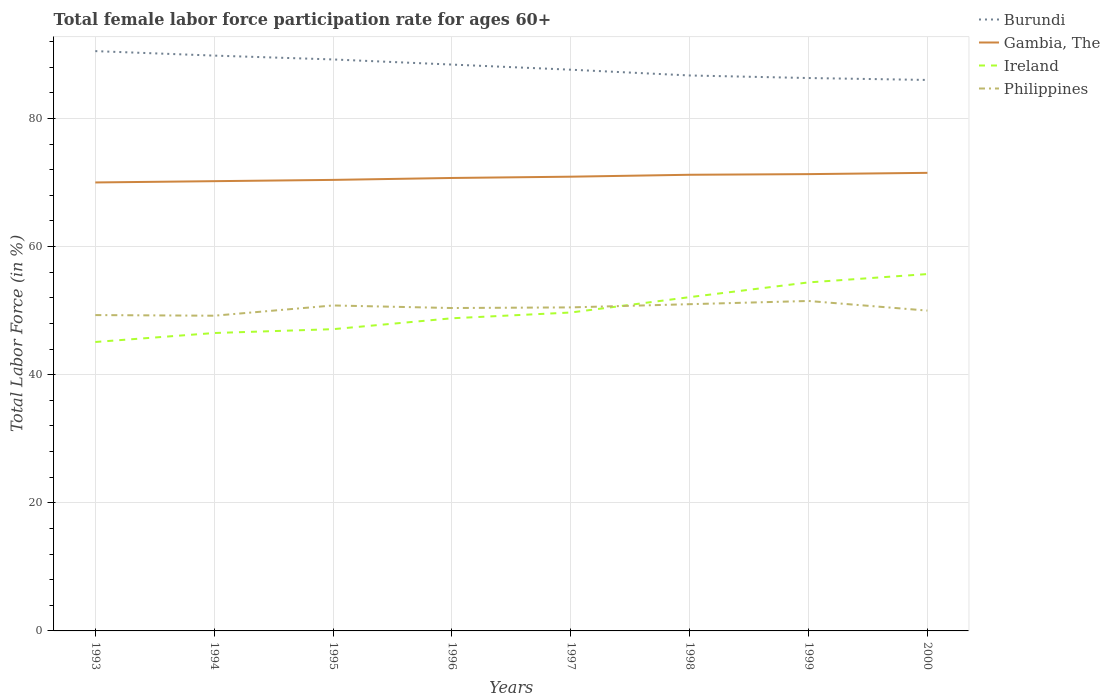How many different coloured lines are there?
Your response must be concise. 4. Does the line corresponding to Burundi intersect with the line corresponding to Ireland?
Offer a terse response. No. Across all years, what is the maximum female labor force participation rate in Philippines?
Provide a succinct answer. 49.2. In which year was the female labor force participation rate in Philippines maximum?
Provide a short and direct response. 1994. What is the total female labor force participation rate in Burundi in the graph?
Provide a succinct answer. 3.1. What is the difference between the highest and the second highest female labor force participation rate in Gambia, The?
Give a very brief answer. 1.5. What is the difference between the highest and the lowest female labor force participation rate in Ireland?
Provide a succinct answer. 3. Is the female labor force participation rate in Philippines strictly greater than the female labor force participation rate in Ireland over the years?
Your answer should be compact. No. How many years are there in the graph?
Give a very brief answer. 8. Are the values on the major ticks of Y-axis written in scientific E-notation?
Your answer should be compact. No. Does the graph contain any zero values?
Your answer should be compact. No. Where does the legend appear in the graph?
Your answer should be very brief. Top right. What is the title of the graph?
Give a very brief answer. Total female labor force participation rate for ages 60+. Does "Bosnia and Herzegovina" appear as one of the legend labels in the graph?
Give a very brief answer. No. What is the Total Labor Force (in %) of Burundi in 1993?
Give a very brief answer. 90.5. What is the Total Labor Force (in %) of Ireland in 1993?
Your response must be concise. 45.1. What is the Total Labor Force (in %) of Philippines in 1993?
Give a very brief answer. 49.3. What is the Total Labor Force (in %) of Burundi in 1994?
Keep it short and to the point. 89.8. What is the Total Labor Force (in %) in Gambia, The in 1994?
Provide a succinct answer. 70.2. What is the Total Labor Force (in %) of Ireland in 1994?
Provide a succinct answer. 46.5. What is the Total Labor Force (in %) of Philippines in 1994?
Keep it short and to the point. 49.2. What is the Total Labor Force (in %) in Burundi in 1995?
Give a very brief answer. 89.2. What is the Total Labor Force (in %) in Gambia, The in 1995?
Offer a very short reply. 70.4. What is the Total Labor Force (in %) in Ireland in 1995?
Offer a very short reply. 47.1. What is the Total Labor Force (in %) in Philippines in 1995?
Keep it short and to the point. 50.8. What is the Total Labor Force (in %) in Burundi in 1996?
Give a very brief answer. 88.4. What is the Total Labor Force (in %) of Gambia, The in 1996?
Your answer should be very brief. 70.7. What is the Total Labor Force (in %) of Ireland in 1996?
Offer a very short reply. 48.8. What is the Total Labor Force (in %) of Philippines in 1996?
Offer a very short reply. 50.4. What is the Total Labor Force (in %) of Burundi in 1997?
Provide a succinct answer. 87.6. What is the Total Labor Force (in %) in Gambia, The in 1997?
Provide a short and direct response. 70.9. What is the Total Labor Force (in %) in Ireland in 1997?
Your response must be concise. 49.7. What is the Total Labor Force (in %) of Philippines in 1997?
Give a very brief answer. 50.5. What is the Total Labor Force (in %) of Burundi in 1998?
Make the answer very short. 86.7. What is the Total Labor Force (in %) of Gambia, The in 1998?
Your response must be concise. 71.2. What is the Total Labor Force (in %) in Ireland in 1998?
Offer a terse response. 52.1. What is the Total Labor Force (in %) of Burundi in 1999?
Keep it short and to the point. 86.3. What is the Total Labor Force (in %) in Gambia, The in 1999?
Ensure brevity in your answer.  71.3. What is the Total Labor Force (in %) of Ireland in 1999?
Keep it short and to the point. 54.4. What is the Total Labor Force (in %) in Philippines in 1999?
Offer a terse response. 51.5. What is the Total Labor Force (in %) in Burundi in 2000?
Ensure brevity in your answer.  86. What is the Total Labor Force (in %) of Gambia, The in 2000?
Provide a succinct answer. 71.5. What is the Total Labor Force (in %) of Ireland in 2000?
Make the answer very short. 55.7. Across all years, what is the maximum Total Labor Force (in %) in Burundi?
Provide a short and direct response. 90.5. Across all years, what is the maximum Total Labor Force (in %) in Gambia, The?
Keep it short and to the point. 71.5. Across all years, what is the maximum Total Labor Force (in %) in Ireland?
Provide a succinct answer. 55.7. Across all years, what is the maximum Total Labor Force (in %) of Philippines?
Provide a succinct answer. 51.5. Across all years, what is the minimum Total Labor Force (in %) of Ireland?
Your answer should be very brief. 45.1. Across all years, what is the minimum Total Labor Force (in %) of Philippines?
Your answer should be compact. 49.2. What is the total Total Labor Force (in %) in Burundi in the graph?
Your answer should be compact. 704.5. What is the total Total Labor Force (in %) in Gambia, The in the graph?
Offer a very short reply. 566.2. What is the total Total Labor Force (in %) of Ireland in the graph?
Ensure brevity in your answer.  399.4. What is the total Total Labor Force (in %) of Philippines in the graph?
Give a very brief answer. 402.7. What is the difference between the Total Labor Force (in %) of Ireland in 1993 and that in 1994?
Offer a very short reply. -1.4. What is the difference between the Total Labor Force (in %) in Burundi in 1993 and that in 1995?
Offer a very short reply. 1.3. What is the difference between the Total Labor Force (in %) in Gambia, The in 1993 and that in 1995?
Provide a succinct answer. -0.4. What is the difference between the Total Labor Force (in %) of Philippines in 1993 and that in 1995?
Your response must be concise. -1.5. What is the difference between the Total Labor Force (in %) of Gambia, The in 1993 and that in 1996?
Keep it short and to the point. -0.7. What is the difference between the Total Labor Force (in %) of Ireland in 1993 and that in 1996?
Your answer should be very brief. -3.7. What is the difference between the Total Labor Force (in %) of Gambia, The in 1993 and that in 1997?
Your answer should be very brief. -0.9. What is the difference between the Total Labor Force (in %) of Ireland in 1993 and that in 1997?
Offer a very short reply. -4.6. What is the difference between the Total Labor Force (in %) in Philippines in 1993 and that in 1998?
Offer a terse response. -1.7. What is the difference between the Total Labor Force (in %) of Philippines in 1993 and that in 1999?
Provide a succinct answer. -2.2. What is the difference between the Total Labor Force (in %) of Burundi in 1993 and that in 2000?
Keep it short and to the point. 4.5. What is the difference between the Total Labor Force (in %) of Philippines in 1993 and that in 2000?
Provide a short and direct response. -0.7. What is the difference between the Total Labor Force (in %) in Burundi in 1994 and that in 1995?
Provide a short and direct response. 0.6. What is the difference between the Total Labor Force (in %) of Gambia, The in 1994 and that in 1995?
Keep it short and to the point. -0.2. What is the difference between the Total Labor Force (in %) in Ireland in 1994 and that in 1995?
Offer a very short reply. -0.6. What is the difference between the Total Labor Force (in %) of Gambia, The in 1994 and that in 1996?
Give a very brief answer. -0.5. What is the difference between the Total Labor Force (in %) in Ireland in 1994 and that in 1996?
Offer a terse response. -2.3. What is the difference between the Total Labor Force (in %) of Burundi in 1994 and that in 1997?
Your response must be concise. 2.2. What is the difference between the Total Labor Force (in %) of Burundi in 1994 and that in 1998?
Keep it short and to the point. 3.1. What is the difference between the Total Labor Force (in %) in Burundi in 1994 and that in 1999?
Provide a short and direct response. 3.5. What is the difference between the Total Labor Force (in %) in Gambia, The in 1994 and that in 1999?
Provide a short and direct response. -1.1. What is the difference between the Total Labor Force (in %) in Philippines in 1994 and that in 1999?
Your answer should be compact. -2.3. What is the difference between the Total Labor Force (in %) of Ireland in 1994 and that in 2000?
Keep it short and to the point. -9.2. What is the difference between the Total Labor Force (in %) of Philippines in 1994 and that in 2000?
Your answer should be compact. -0.8. What is the difference between the Total Labor Force (in %) in Burundi in 1995 and that in 1996?
Offer a very short reply. 0.8. What is the difference between the Total Labor Force (in %) of Gambia, The in 1995 and that in 1996?
Your answer should be very brief. -0.3. What is the difference between the Total Labor Force (in %) of Philippines in 1995 and that in 1996?
Provide a succinct answer. 0.4. What is the difference between the Total Labor Force (in %) of Gambia, The in 1995 and that in 1997?
Your response must be concise. -0.5. What is the difference between the Total Labor Force (in %) of Philippines in 1995 and that in 1997?
Your response must be concise. 0.3. What is the difference between the Total Labor Force (in %) in Burundi in 1995 and that in 1998?
Your response must be concise. 2.5. What is the difference between the Total Labor Force (in %) in Philippines in 1995 and that in 1998?
Your answer should be very brief. -0.2. What is the difference between the Total Labor Force (in %) in Burundi in 1995 and that in 1999?
Make the answer very short. 2.9. What is the difference between the Total Labor Force (in %) in Gambia, The in 1995 and that in 1999?
Keep it short and to the point. -0.9. What is the difference between the Total Labor Force (in %) of Philippines in 1995 and that in 1999?
Ensure brevity in your answer.  -0.7. What is the difference between the Total Labor Force (in %) of Burundi in 1995 and that in 2000?
Provide a short and direct response. 3.2. What is the difference between the Total Labor Force (in %) of Philippines in 1995 and that in 2000?
Offer a very short reply. 0.8. What is the difference between the Total Labor Force (in %) of Burundi in 1996 and that in 1997?
Ensure brevity in your answer.  0.8. What is the difference between the Total Labor Force (in %) of Burundi in 1996 and that in 1999?
Keep it short and to the point. 2.1. What is the difference between the Total Labor Force (in %) of Gambia, The in 1996 and that in 1999?
Ensure brevity in your answer.  -0.6. What is the difference between the Total Labor Force (in %) of Ireland in 1996 and that in 1999?
Offer a terse response. -5.6. What is the difference between the Total Labor Force (in %) of Ireland in 1996 and that in 2000?
Ensure brevity in your answer.  -6.9. What is the difference between the Total Labor Force (in %) of Burundi in 1997 and that in 1998?
Offer a terse response. 0.9. What is the difference between the Total Labor Force (in %) in Ireland in 1997 and that in 1998?
Offer a terse response. -2.4. What is the difference between the Total Labor Force (in %) in Burundi in 1997 and that in 1999?
Your response must be concise. 1.3. What is the difference between the Total Labor Force (in %) in Philippines in 1997 and that in 1999?
Provide a short and direct response. -1. What is the difference between the Total Labor Force (in %) in Philippines in 1997 and that in 2000?
Keep it short and to the point. 0.5. What is the difference between the Total Labor Force (in %) in Burundi in 1998 and that in 1999?
Keep it short and to the point. 0.4. What is the difference between the Total Labor Force (in %) in Gambia, The in 1998 and that in 1999?
Provide a short and direct response. -0.1. What is the difference between the Total Labor Force (in %) in Philippines in 1998 and that in 1999?
Your answer should be very brief. -0.5. What is the difference between the Total Labor Force (in %) in Gambia, The in 1998 and that in 2000?
Ensure brevity in your answer.  -0.3. What is the difference between the Total Labor Force (in %) in Ireland in 1998 and that in 2000?
Make the answer very short. -3.6. What is the difference between the Total Labor Force (in %) in Philippines in 1999 and that in 2000?
Offer a terse response. 1.5. What is the difference between the Total Labor Force (in %) of Burundi in 1993 and the Total Labor Force (in %) of Gambia, The in 1994?
Offer a very short reply. 20.3. What is the difference between the Total Labor Force (in %) of Burundi in 1993 and the Total Labor Force (in %) of Ireland in 1994?
Provide a short and direct response. 44. What is the difference between the Total Labor Force (in %) of Burundi in 1993 and the Total Labor Force (in %) of Philippines in 1994?
Offer a terse response. 41.3. What is the difference between the Total Labor Force (in %) of Gambia, The in 1993 and the Total Labor Force (in %) of Ireland in 1994?
Offer a very short reply. 23.5. What is the difference between the Total Labor Force (in %) in Gambia, The in 1993 and the Total Labor Force (in %) in Philippines in 1994?
Offer a terse response. 20.8. What is the difference between the Total Labor Force (in %) of Burundi in 1993 and the Total Labor Force (in %) of Gambia, The in 1995?
Make the answer very short. 20.1. What is the difference between the Total Labor Force (in %) of Burundi in 1993 and the Total Labor Force (in %) of Ireland in 1995?
Keep it short and to the point. 43.4. What is the difference between the Total Labor Force (in %) in Burundi in 1993 and the Total Labor Force (in %) in Philippines in 1995?
Offer a terse response. 39.7. What is the difference between the Total Labor Force (in %) in Gambia, The in 1993 and the Total Labor Force (in %) in Ireland in 1995?
Ensure brevity in your answer.  22.9. What is the difference between the Total Labor Force (in %) of Gambia, The in 1993 and the Total Labor Force (in %) of Philippines in 1995?
Provide a short and direct response. 19.2. What is the difference between the Total Labor Force (in %) in Burundi in 1993 and the Total Labor Force (in %) in Gambia, The in 1996?
Your answer should be very brief. 19.8. What is the difference between the Total Labor Force (in %) in Burundi in 1993 and the Total Labor Force (in %) in Ireland in 1996?
Your response must be concise. 41.7. What is the difference between the Total Labor Force (in %) of Burundi in 1993 and the Total Labor Force (in %) of Philippines in 1996?
Offer a very short reply. 40.1. What is the difference between the Total Labor Force (in %) of Gambia, The in 1993 and the Total Labor Force (in %) of Ireland in 1996?
Provide a succinct answer. 21.2. What is the difference between the Total Labor Force (in %) of Gambia, The in 1993 and the Total Labor Force (in %) of Philippines in 1996?
Your answer should be compact. 19.6. What is the difference between the Total Labor Force (in %) in Burundi in 1993 and the Total Labor Force (in %) in Gambia, The in 1997?
Provide a short and direct response. 19.6. What is the difference between the Total Labor Force (in %) of Burundi in 1993 and the Total Labor Force (in %) of Ireland in 1997?
Provide a succinct answer. 40.8. What is the difference between the Total Labor Force (in %) of Gambia, The in 1993 and the Total Labor Force (in %) of Ireland in 1997?
Your answer should be very brief. 20.3. What is the difference between the Total Labor Force (in %) of Ireland in 1993 and the Total Labor Force (in %) of Philippines in 1997?
Ensure brevity in your answer.  -5.4. What is the difference between the Total Labor Force (in %) of Burundi in 1993 and the Total Labor Force (in %) of Gambia, The in 1998?
Keep it short and to the point. 19.3. What is the difference between the Total Labor Force (in %) of Burundi in 1993 and the Total Labor Force (in %) of Ireland in 1998?
Your response must be concise. 38.4. What is the difference between the Total Labor Force (in %) of Burundi in 1993 and the Total Labor Force (in %) of Philippines in 1998?
Your answer should be very brief. 39.5. What is the difference between the Total Labor Force (in %) of Gambia, The in 1993 and the Total Labor Force (in %) of Ireland in 1998?
Provide a succinct answer. 17.9. What is the difference between the Total Labor Force (in %) in Gambia, The in 1993 and the Total Labor Force (in %) in Philippines in 1998?
Your answer should be very brief. 19. What is the difference between the Total Labor Force (in %) of Ireland in 1993 and the Total Labor Force (in %) of Philippines in 1998?
Your response must be concise. -5.9. What is the difference between the Total Labor Force (in %) of Burundi in 1993 and the Total Labor Force (in %) of Gambia, The in 1999?
Offer a very short reply. 19.2. What is the difference between the Total Labor Force (in %) of Burundi in 1993 and the Total Labor Force (in %) of Ireland in 1999?
Your answer should be compact. 36.1. What is the difference between the Total Labor Force (in %) in Gambia, The in 1993 and the Total Labor Force (in %) in Ireland in 1999?
Give a very brief answer. 15.6. What is the difference between the Total Labor Force (in %) in Burundi in 1993 and the Total Labor Force (in %) in Ireland in 2000?
Keep it short and to the point. 34.8. What is the difference between the Total Labor Force (in %) of Burundi in 1993 and the Total Labor Force (in %) of Philippines in 2000?
Make the answer very short. 40.5. What is the difference between the Total Labor Force (in %) in Gambia, The in 1993 and the Total Labor Force (in %) in Ireland in 2000?
Ensure brevity in your answer.  14.3. What is the difference between the Total Labor Force (in %) in Gambia, The in 1993 and the Total Labor Force (in %) in Philippines in 2000?
Provide a short and direct response. 20. What is the difference between the Total Labor Force (in %) in Ireland in 1993 and the Total Labor Force (in %) in Philippines in 2000?
Provide a succinct answer. -4.9. What is the difference between the Total Labor Force (in %) in Burundi in 1994 and the Total Labor Force (in %) in Gambia, The in 1995?
Provide a short and direct response. 19.4. What is the difference between the Total Labor Force (in %) in Burundi in 1994 and the Total Labor Force (in %) in Ireland in 1995?
Offer a very short reply. 42.7. What is the difference between the Total Labor Force (in %) of Burundi in 1994 and the Total Labor Force (in %) of Philippines in 1995?
Your response must be concise. 39. What is the difference between the Total Labor Force (in %) of Gambia, The in 1994 and the Total Labor Force (in %) of Ireland in 1995?
Make the answer very short. 23.1. What is the difference between the Total Labor Force (in %) in Burundi in 1994 and the Total Labor Force (in %) in Philippines in 1996?
Keep it short and to the point. 39.4. What is the difference between the Total Labor Force (in %) of Gambia, The in 1994 and the Total Labor Force (in %) of Ireland in 1996?
Make the answer very short. 21.4. What is the difference between the Total Labor Force (in %) of Gambia, The in 1994 and the Total Labor Force (in %) of Philippines in 1996?
Offer a very short reply. 19.8. What is the difference between the Total Labor Force (in %) of Ireland in 1994 and the Total Labor Force (in %) of Philippines in 1996?
Provide a short and direct response. -3.9. What is the difference between the Total Labor Force (in %) of Burundi in 1994 and the Total Labor Force (in %) of Ireland in 1997?
Your answer should be compact. 40.1. What is the difference between the Total Labor Force (in %) in Burundi in 1994 and the Total Labor Force (in %) in Philippines in 1997?
Offer a terse response. 39.3. What is the difference between the Total Labor Force (in %) of Gambia, The in 1994 and the Total Labor Force (in %) of Philippines in 1997?
Offer a terse response. 19.7. What is the difference between the Total Labor Force (in %) of Burundi in 1994 and the Total Labor Force (in %) of Gambia, The in 1998?
Your response must be concise. 18.6. What is the difference between the Total Labor Force (in %) of Burundi in 1994 and the Total Labor Force (in %) of Ireland in 1998?
Offer a terse response. 37.7. What is the difference between the Total Labor Force (in %) in Burundi in 1994 and the Total Labor Force (in %) in Philippines in 1998?
Provide a succinct answer. 38.8. What is the difference between the Total Labor Force (in %) of Gambia, The in 1994 and the Total Labor Force (in %) of Philippines in 1998?
Ensure brevity in your answer.  19.2. What is the difference between the Total Labor Force (in %) in Ireland in 1994 and the Total Labor Force (in %) in Philippines in 1998?
Your answer should be compact. -4.5. What is the difference between the Total Labor Force (in %) of Burundi in 1994 and the Total Labor Force (in %) of Ireland in 1999?
Your answer should be very brief. 35.4. What is the difference between the Total Labor Force (in %) of Burundi in 1994 and the Total Labor Force (in %) of Philippines in 1999?
Offer a terse response. 38.3. What is the difference between the Total Labor Force (in %) in Gambia, The in 1994 and the Total Labor Force (in %) in Ireland in 1999?
Offer a very short reply. 15.8. What is the difference between the Total Labor Force (in %) of Gambia, The in 1994 and the Total Labor Force (in %) of Philippines in 1999?
Keep it short and to the point. 18.7. What is the difference between the Total Labor Force (in %) in Ireland in 1994 and the Total Labor Force (in %) in Philippines in 1999?
Your answer should be very brief. -5. What is the difference between the Total Labor Force (in %) of Burundi in 1994 and the Total Labor Force (in %) of Ireland in 2000?
Ensure brevity in your answer.  34.1. What is the difference between the Total Labor Force (in %) of Burundi in 1994 and the Total Labor Force (in %) of Philippines in 2000?
Ensure brevity in your answer.  39.8. What is the difference between the Total Labor Force (in %) of Gambia, The in 1994 and the Total Labor Force (in %) of Ireland in 2000?
Your answer should be very brief. 14.5. What is the difference between the Total Labor Force (in %) of Gambia, The in 1994 and the Total Labor Force (in %) of Philippines in 2000?
Make the answer very short. 20.2. What is the difference between the Total Labor Force (in %) in Burundi in 1995 and the Total Labor Force (in %) in Gambia, The in 1996?
Give a very brief answer. 18.5. What is the difference between the Total Labor Force (in %) in Burundi in 1995 and the Total Labor Force (in %) in Ireland in 1996?
Your answer should be very brief. 40.4. What is the difference between the Total Labor Force (in %) of Burundi in 1995 and the Total Labor Force (in %) of Philippines in 1996?
Give a very brief answer. 38.8. What is the difference between the Total Labor Force (in %) of Gambia, The in 1995 and the Total Labor Force (in %) of Ireland in 1996?
Your response must be concise. 21.6. What is the difference between the Total Labor Force (in %) of Gambia, The in 1995 and the Total Labor Force (in %) of Philippines in 1996?
Keep it short and to the point. 20. What is the difference between the Total Labor Force (in %) in Burundi in 1995 and the Total Labor Force (in %) in Ireland in 1997?
Provide a short and direct response. 39.5. What is the difference between the Total Labor Force (in %) of Burundi in 1995 and the Total Labor Force (in %) of Philippines in 1997?
Provide a succinct answer. 38.7. What is the difference between the Total Labor Force (in %) of Gambia, The in 1995 and the Total Labor Force (in %) of Ireland in 1997?
Keep it short and to the point. 20.7. What is the difference between the Total Labor Force (in %) in Burundi in 1995 and the Total Labor Force (in %) in Gambia, The in 1998?
Ensure brevity in your answer.  18. What is the difference between the Total Labor Force (in %) of Burundi in 1995 and the Total Labor Force (in %) of Ireland in 1998?
Make the answer very short. 37.1. What is the difference between the Total Labor Force (in %) of Burundi in 1995 and the Total Labor Force (in %) of Philippines in 1998?
Your response must be concise. 38.2. What is the difference between the Total Labor Force (in %) of Gambia, The in 1995 and the Total Labor Force (in %) of Ireland in 1998?
Your response must be concise. 18.3. What is the difference between the Total Labor Force (in %) of Ireland in 1995 and the Total Labor Force (in %) of Philippines in 1998?
Give a very brief answer. -3.9. What is the difference between the Total Labor Force (in %) in Burundi in 1995 and the Total Labor Force (in %) in Gambia, The in 1999?
Ensure brevity in your answer.  17.9. What is the difference between the Total Labor Force (in %) of Burundi in 1995 and the Total Labor Force (in %) of Ireland in 1999?
Your answer should be compact. 34.8. What is the difference between the Total Labor Force (in %) in Burundi in 1995 and the Total Labor Force (in %) in Philippines in 1999?
Ensure brevity in your answer.  37.7. What is the difference between the Total Labor Force (in %) in Gambia, The in 1995 and the Total Labor Force (in %) in Ireland in 1999?
Provide a succinct answer. 16. What is the difference between the Total Labor Force (in %) of Gambia, The in 1995 and the Total Labor Force (in %) of Philippines in 1999?
Make the answer very short. 18.9. What is the difference between the Total Labor Force (in %) of Ireland in 1995 and the Total Labor Force (in %) of Philippines in 1999?
Provide a succinct answer. -4.4. What is the difference between the Total Labor Force (in %) of Burundi in 1995 and the Total Labor Force (in %) of Ireland in 2000?
Your answer should be compact. 33.5. What is the difference between the Total Labor Force (in %) of Burundi in 1995 and the Total Labor Force (in %) of Philippines in 2000?
Ensure brevity in your answer.  39.2. What is the difference between the Total Labor Force (in %) in Gambia, The in 1995 and the Total Labor Force (in %) in Philippines in 2000?
Offer a terse response. 20.4. What is the difference between the Total Labor Force (in %) of Burundi in 1996 and the Total Labor Force (in %) of Gambia, The in 1997?
Keep it short and to the point. 17.5. What is the difference between the Total Labor Force (in %) in Burundi in 1996 and the Total Labor Force (in %) in Ireland in 1997?
Your answer should be very brief. 38.7. What is the difference between the Total Labor Force (in %) of Burundi in 1996 and the Total Labor Force (in %) of Philippines in 1997?
Provide a short and direct response. 37.9. What is the difference between the Total Labor Force (in %) of Gambia, The in 1996 and the Total Labor Force (in %) of Philippines in 1997?
Your answer should be compact. 20.2. What is the difference between the Total Labor Force (in %) of Ireland in 1996 and the Total Labor Force (in %) of Philippines in 1997?
Give a very brief answer. -1.7. What is the difference between the Total Labor Force (in %) of Burundi in 1996 and the Total Labor Force (in %) of Gambia, The in 1998?
Your answer should be very brief. 17.2. What is the difference between the Total Labor Force (in %) of Burundi in 1996 and the Total Labor Force (in %) of Ireland in 1998?
Give a very brief answer. 36.3. What is the difference between the Total Labor Force (in %) in Burundi in 1996 and the Total Labor Force (in %) in Philippines in 1998?
Ensure brevity in your answer.  37.4. What is the difference between the Total Labor Force (in %) of Gambia, The in 1996 and the Total Labor Force (in %) of Philippines in 1998?
Provide a short and direct response. 19.7. What is the difference between the Total Labor Force (in %) in Burundi in 1996 and the Total Labor Force (in %) in Gambia, The in 1999?
Provide a succinct answer. 17.1. What is the difference between the Total Labor Force (in %) in Burundi in 1996 and the Total Labor Force (in %) in Ireland in 1999?
Your answer should be compact. 34. What is the difference between the Total Labor Force (in %) in Burundi in 1996 and the Total Labor Force (in %) in Philippines in 1999?
Ensure brevity in your answer.  36.9. What is the difference between the Total Labor Force (in %) in Gambia, The in 1996 and the Total Labor Force (in %) in Philippines in 1999?
Keep it short and to the point. 19.2. What is the difference between the Total Labor Force (in %) in Burundi in 1996 and the Total Labor Force (in %) in Ireland in 2000?
Offer a very short reply. 32.7. What is the difference between the Total Labor Force (in %) in Burundi in 1996 and the Total Labor Force (in %) in Philippines in 2000?
Keep it short and to the point. 38.4. What is the difference between the Total Labor Force (in %) in Gambia, The in 1996 and the Total Labor Force (in %) in Philippines in 2000?
Keep it short and to the point. 20.7. What is the difference between the Total Labor Force (in %) in Ireland in 1996 and the Total Labor Force (in %) in Philippines in 2000?
Keep it short and to the point. -1.2. What is the difference between the Total Labor Force (in %) in Burundi in 1997 and the Total Labor Force (in %) in Ireland in 1998?
Your answer should be very brief. 35.5. What is the difference between the Total Labor Force (in %) in Burundi in 1997 and the Total Labor Force (in %) in Philippines in 1998?
Your answer should be very brief. 36.6. What is the difference between the Total Labor Force (in %) of Burundi in 1997 and the Total Labor Force (in %) of Gambia, The in 1999?
Provide a succinct answer. 16.3. What is the difference between the Total Labor Force (in %) in Burundi in 1997 and the Total Labor Force (in %) in Ireland in 1999?
Offer a very short reply. 33.2. What is the difference between the Total Labor Force (in %) of Burundi in 1997 and the Total Labor Force (in %) of Philippines in 1999?
Your response must be concise. 36.1. What is the difference between the Total Labor Force (in %) in Gambia, The in 1997 and the Total Labor Force (in %) in Philippines in 1999?
Offer a very short reply. 19.4. What is the difference between the Total Labor Force (in %) in Ireland in 1997 and the Total Labor Force (in %) in Philippines in 1999?
Your answer should be compact. -1.8. What is the difference between the Total Labor Force (in %) in Burundi in 1997 and the Total Labor Force (in %) in Gambia, The in 2000?
Keep it short and to the point. 16.1. What is the difference between the Total Labor Force (in %) in Burundi in 1997 and the Total Labor Force (in %) in Ireland in 2000?
Provide a short and direct response. 31.9. What is the difference between the Total Labor Force (in %) in Burundi in 1997 and the Total Labor Force (in %) in Philippines in 2000?
Your answer should be compact. 37.6. What is the difference between the Total Labor Force (in %) of Gambia, The in 1997 and the Total Labor Force (in %) of Philippines in 2000?
Your response must be concise. 20.9. What is the difference between the Total Labor Force (in %) in Ireland in 1997 and the Total Labor Force (in %) in Philippines in 2000?
Ensure brevity in your answer.  -0.3. What is the difference between the Total Labor Force (in %) in Burundi in 1998 and the Total Labor Force (in %) in Ireland in 1999?
Give a very brief answer. 32.3. What is the difference between the Total Labor Force (in %) of Burundi in 1998 and the Total Labor Force (in %) of Philippines in 1999?
Provide a succinct answer. 35.2. What is the difference between the Total Labor Force (in %) of Gambia, The in 1998 and the Total Labor Force (in %) of Philippines in 1999?
Offer a very short reply. 19.7. What is the difference between the Total Labor Force (in %) in Burundi in 1998 and the Total Labor Force (in %) in Ireland in 2000?
Your answer should be compact. 31. What is the difference between the Total Labor Force (in %) in Burundi in 1998 and the Total Labor Force (in %) in Philippines in 2000?
Your response must be concise. 36.7. What is the difference between the Total Labor Force (in %) of Gambia, The in 1998 and the Total Labor Force (in %) of Ireland in 2000?
Your answer should be very brief. 15.5. What is the difference between the Total Labor Force (in %) of Gambia, The in 1998 and the Total Labor Force (in %) of Philippines in 2000?
Provide a succinct answer. 21.2. What is the difference between the Total Labor Force (in %) of Ireland in 1998 and the Total Labor Force (in %) of Philippines in 2000?
Ensure brevity in your answer.  2.1. What is the difference between the Total Labor Force (in %) in Burundi in 1999 and the Total Labor Force (in %) in Gambia, The in 2000?
Your response must be concise. 14.8. What is the difference between the Total Labor Force (in %) of Burundi in 1999 and the Total Labor Force (in %) of Ireland in 2000?
Make the answer very short. 30.6. What is the difference between the Total Labor Force (in %) of Burundi in 1999 and the Total Labor Force (in %) of Philippines in 2000?
Keep it short and to the point. 36.3. What is the difference between the Total Labor Force (in %) of Gambia, The in 1999 and the Total Labor Force (in %) of Ireland in 2000?
Keep it short and to the point. 15.6. What is the difference between the Total Labor Force (in %) of Gambia, The in 1999 and the Total Labor Force (in %) of Philippines in 2000?
Make the answer very short. 21.3. What is the difference between the Total Labor Force (in %) in Ireland in 1999 and the Total Labor Force (in %) in Philippines in 2000?
Your response must be concise. 4.4. What is the average Total Labor Force (in %) of Burundi per year?
Give a very brief answer. 88.06. What is the average Total Labor Force (in %) in Gambia, The per year?
Provide a succinct answer. 70.78. What is the average Total Labor Force (in %) in Ireland per year?
Make the answer very short. 49.92. What is the average Total Labor Force (in %) in Philippines per year?
Offer a very short reply. 50.34. In the year 1993, what is the difference between the Total Labor Force (in %) of Burundi and Total Labor Force (in %) of Ireland?
Make the answer very short. 45.4. In the year 1993, what is the difference between the Total Labor Force (in %) of Burundi and Total Labor Force (in %) of Philippines?
Offer a very short reply. 41.2. In the year 1993, what is the difference between the Total Labor Force (in %) of Gambia, The and Total Labor Force (in %) of Ireland?
Keep it short and to the point. 24.9. In the year 1993, what is the difference between the Total Labor Force (in %) in Gambia, The and Total Labor Force (in %) in Philippines?
Make the answer very short. 20.7. In the year 1993, what is the difference between the Total Labor Force (in %) of Ireland and Total Labor Force (in %) of Philippines?
Your response must be concise. -4.2. In the year 1994, what is the difference between the Total Labor Force (in %) of Burundi and Total Labor Force (in %) of Gambia, The?
Offer a very short reply. 19.6. In the year 1994, what is the difference between the Total Labor Force (in %) in Burundi and Total Labor Force (in %) in Ireland?
Offer a terse response. 43.3. In the year 1994, what is the difference between the Total Labor Force (in %) in Burundi and Total Labor Force (in %) in Philippines?
Offer a very short reply. 40.6. In the year 1994, what is the difference between the Total Labor Force (in %) in Gambia, The and Total Labor Force (in %) in Ireland?
Give a very brief answer. 23.7. In the year 1994, what is the difference between the Total Labor Force (in %) of Gambia, The and Total Labor Force (in %) of Philippines?
Provide a short and direct response. 21. In the year 1995, what is the difference between the Total Labor Force (in %) in Burundi and Total Labor Force (in %) in Gambia, The?
Provide a short and direct response. 18.8. In the year 1995, what is the difference between the Total Labor Force (in %) of Burundi and Total Labor Force (in %) of Ireland?
Keep it short and to the point. 42.1. In the year 1995, what is the difference between the Total Labor Force (in %) in Burundi and Total Labor Force (in %) in Philippines?
Keep it short and to the point. 38.4. In the year 1995, what is the difference between the Total Labor Force (in %) in Gambia, The and Total Labor Force (in %) in Ireland?
Your response must be concise. 23.3. In the year 1995, what is the difference between the Total Labor Force (in %) in Gambia, The and Total Labor Force (in %) in Philippines?
Your response must be concise. 19.6. In the year 1995, what is the difference between the Total Labor Force (in %) in Ireland and Total Labor Force (in %) in Philippines?
Your response must be concise. -3.7. In the year 1996, what is the difference between the Total Labor Force (in %) in Burundi and Total Labor Force (in %) in Ireland?
Provide a succinct answer. 39.6. In the year 1996, what is the difference between the Total Labor Force (in %) in Gambia, The and Total Labor Force (in %) in Ireland?
Keep it short and to the point. 21.9. In the year 1996, what is the difference between the Total Labor Force (in %) of Gambia, The and Total Labor Force (in %) of Philippines?
Your answer should be compact. 20.3. In the year 1997, what is the difference between the Total Labor Force (in %) in Burundi and Total Labor Force (in %) in Ireland?
Your response must be concise. 37.9. In the year 1997, what is the difference between the Total Labor Force (in %) of Burundi and Total Labor Force (in %) of Philippines?
Provide a succinct answer. 37.1. In the year 1997, what is the difference between the Total Labor Force (in %) in Gambia, The and Total Labor Force (in %) in Ireland?
Make the answer very short. 21.2. In the year 1997, what is the difference between the Total Labor Force (in %) of Gambia, The and Total Labor Force (in %) of Philippines?
Your answer should be very brief. 20.4. In the year 1998, what is the difference between the Total Labor Force (in %) in Burundi and Total Labor Force (in %) in Ireland?
Your answer should be compact. 34.6. In the year 1998, what is the difference between the Total Labor Force (in %) of Burundi and Total Labor Force (in %) of Philippines?
Keep it short and to the point. 35.7. In the year 1998, what is the difference between the Total Labor Force (in %) in Gambia, The and Total Labor Force (in %) in Ireland?
Make the answer very short. 19.1. In the year 1998, what is the difference between the Total Labor Force (in %) of Gambia, The and Total Labor Force (in %) of Philippines?
Offer a very short reply. 20.2. In the year 1998, what is the difference between the Total Labor Force (in %) in Ireland and Total Labor Force (in %) in Philippines?
Your response must be concise. 1.1. In the year 1999, what is the difference between the Total Labor Force (in %) of Burundi and Total Labor Force (in %) of Gambia, The?
Ensure brevity in your answer.  15. In the year 1999, what is the difference between the Total Labor Force (in %) in Burundi and Total Labor Force (in %) in Ireland?
Provide a short and direct response. 31.9. In the year 1999, what is the difference between the Total Labor Force (in %) in Burundi and Total Labor Force (in %) in Philippines?
Provide a short and direct response. 34.8. In the year 1999, what is the difference between the Total Labor Force (in %) in Gambia, The and Total Labor Force (in %) in Philippines?
Offer a very short reply. 19.8. In the year 2000, what is the difference between the Total Labor Force (in %) in Burundi and Total Labor Force (in %) in Gambia, The?
Your response must be concise. 14.5. In the year 2000, what is the difference between the Total Labor Force (in %) of Burundi and Total Labor Force (in %) of Ireland?
Keep it short and to the point. 30.3. In the year 2000, what is the difference between the Total Labor Force (in %) of Gambia, The and Total Labor Force (in %) of Philippines?
Make the answer very short. 21.5. What is the ratio of the Total Labor Force (in %) in Burundi in 1993 to that in 1994?
Provide a succinct answer. 1.01. What is the ratio of the Total Labor Force (in %) in Ireland in 1993 to that in 1994?
Make the answer very short. 0.97. What is the ratio of the Total Labor Force (in %) of Philippines in 1993 to that in 1994?
Your response must be concise. 1. What is the ratio of the Total Labor Force (in %) in Burundi in 1993 to that in 1995?
Offer a terse response. 1.01. What is the ratio of the Total Labor Force (in %) of Gambia, The in 1993 to that in 1995?
Provide a short and direct response. 0.99. What is the ratio of the Total Labor Force (in %) in Ireland in 1993 to that in 1995?
Keep it short and to the point. 0.96. What is the ratio of the Total Labor Force (in %) of Philippines in 1993 to that in 1995?
Give a very brief answer. 0.97. What is the ratio of the Total Labor Force (in %) in Burundi in 1993 to that in 1996?
Your response must be concise. 1.02. What is the ratio of the Total Labor Force (in %) in Gambia, The in 1993 to that in 1996?
Your answer should be compact. 0.99. What is the ratio of the Total Labor Force (in %) in Ireland in 1993 to that in 1996?
Your answer should be very brief. 0.92. What is the ratio of the Total Labor Force (in %) in Philippines in 1993 to that in 1996?
Give a very brief answer. 0.98. What is the ratio of the Total Labor Force (in %) in Burundi in 1993 to that in 1997?
Your answer should be very brief. 1.03. What is the ratio of the Total Labor Force (in %) of Gambia, The in 1993 to that in 1997?
Offer a terse response. 0.99. What is the ratio of the Total Labor Force (in %) in Ireland in 1993 to that in 1997?
Your answer should be compact. 0.91. What is the ratio of the Total Labor Force (in %) of Philippines in 1993 to that in 1997?
Your response must be concise. 0.98. What is the ratio of the Total Labor Force (in %) in Burundi in 1993 to that in 1998?
Provide a short and direct response. 1.04. What is the ratio of the Total Labor Force (in %) of Gambia, The in 1993 to that in 1998?
Offer a terse response. 0.98. What is the ratio of the Total Labor Force (in %) in Ireland in 1993 to that in 1998?
Make the answer very short. 0.87. What is the ratio of the Total Labor Force (in %) of Philippines in 1993 to that in 1998?
Your answer should be very brief. 0.97. What is the ratio of the Total Labor Force (in %) in Burundi in 1993 to that in 1999?
Your answer should be very brief. 1.05. What is the ratio of the Total Labor Force (in %) in Gambia, The in 1993 to that in 1999?
Make the answer very short. 0.98. What is the ratio of the Total Labor Force (in %) of Ireland in 1993 to that in 1999?
Offer a terse response. 0.83. What is the ratio of the Total Labor Force (in %) of Philippines in 1993 to that in 1999?
Give a very brief answer. 0.96. What is the ratio of the Total Labor Force (in %) of Burundi in 1993 to that in 2000?
Ensure brevity in your answer.  1.05. What is the ratio of the Total Labor Force (in %) in Gambia, The in 1993 to that in 2000?
Provide a short and direct response. 0.98. What is the ratio of the Total Labor Force (in %) of Ireland in 1993 to that in 2000?
Provide a short and direct response. 0.81. What is the ratio of the Total Labor Force (in %) in Philippines in 1993 to that in 2000?
Provide a succinct answer. 0.99. What is the ratio of the Total Labor Force (in %) in Ireland in 1994 to that in 1995?
Make the answer very short. 0.99. What is the ratio of the Total Labor Force (in %) in Philippines in 1994 to that in 1995?
Provide a succinct answer. 0.97. What is the ratio of the Total Labor Force (in %) in Burundi in 1994 to that in 1996?
Your answer should be very brief. 1.02. What is the ratio of the Total Labor Force (in %) in Ireland in 1994 to that in 1996?
Make the answer very short. 0.95. What is the ratio of the Total Labor Force (in %) in Philippines in 1994 to that in 1996?
Give a very brief answer. 0.98. What is the ratio of the Total Labor Force (in %) of Burundi in 1994 to that in 1997?
Give a very brief answer. 1.03. What is the ratio of the Total Labor Force (in %) in Ireland in 1994 to that in 1997?
Make the answer very short. 0.94. What is the ratio of the Total Labor Force (in %) of Philippines in 1994 to that in 1997?
Offer a very short reply. 0.97. What is the ratio of the Total Labor Force (in %) of Burundi in 1994 to that in 1998?
Keep it short and to the point. 1.04. What is the ratio of the Total Labor Force (in %) of Gambia, The in 1994 to that in 1998?
Your answer should be very brief. 0.99. What is the ratio of the Total Labor Force (in %) of Ireland in 1994 to that in 1998?
Give a very brief answer. 0.89. What is the ratio of the Total Labor Force (in %) in Philippines in 1994 to that in 1998?
Offer a very short reply. 0.96. What is the ratio of the Total Labor Force (in %) of Burundi in 1994 to that in 1999?
Ensure brevity in your answer.  1.04. What is the ratio of the Total Labor Force (in %) in Gambia, The in 1994 to that in 1999?
Keep it short and to the point. 0.98. What is the ratio of the Total Labor Force (in %) in Ireland in 1994 to that in 1999?
Make the answer very short. 0.85. What is the ratio of the Total Labor Force (in %) of Philippines in 1994 to that in 1999?
Keep it short and to the point. 0.96. What is the ratio of the Total Labor Force (in %) of Burundi in 1994 to that in 2000?
Provide a short and direct response. 1.04. What is the ratio of the Total Labor Force (in %) of Gambia, The in 1994 to that in 2000?
Offer a very short reply. 0.98. What is the ratio of the Total Labor Force (in %) of Ireland in 1994 to that in 2000?
Make the answer very short. 0.83. What is the ratio of the Total Labor Force (in %) in Burundi in 1995 to that in 1996?
Give a very brief answer. 1.01. What is the ratio of the Total Labor Force (in %) in Ireland in 1995 to that in 1996?
Keep it short and to the point. 0.97. What is the ratio of the Total Labor Force (in %) of Philippines in 1995 to that in 1996?
Offer a very short reply. 1.01. What is the ratio of the Total Labor Force (in %) of Burundi in 1995 to that in 1997?
Provide a succinct answer. 1.02. What is the ratio of the Total Labor Force (in %) in Gambia, The in 1995 to that in 1997?
Provide a succinct answer. 0.99. What is the ratio of the Total Labor Force (in %) of Ireland in 1995 to that in 1997?
Make the answer very short. 0.95. What is the ratio of the Total Labor Force (in %) in Philippines in 1995 to that in 1997?
Provide a short and direct response. 1.01. What is the ratio of the Total Labor Force (in %) in Burundi in 1995 to that in 1998?
Provide a short and direct response. 1.03. What is the ratio of the Total Labor Force (in %) in Ireland in 1995 to that in 1998?
Make the answer very short. 0.9. What is the ratio of the Total Labor Force (in %) in Burundi in 1995 to that in 1999?
Provide a succinct answer. 1.03. What is the ratio of the Total Labor Force (in %) in Gambia, The in 1995 to that in 1999?
Offer a very short reply. 0.99. What is the ratio of the Total Labor Force (in %) of Ireland in 1995 to that in 1999?
Keep it short and to the point. 0.87. What is the ratio of the Total Labor Force (in %) in Philippines in 1995 to that in 1999?
Give a very brief answer. 0.99. What is the ratio of the Total Labor Force (in %) in Burundi in 1995 to that in 2000?
Ensure brevity in your answer.  1.04. What is the ratio of the Total Labor Force (in %) in Gambia, The in 1995 to that in 2000?
Give a very brief answer. 0.98. What is the ratio of the Total Labor Force (in %) in Ireland in 1995 to that in 2000?
Your response must be concise. 0.85. What is the ratio of the Total Labor Force (in %) of Philippines in 1995 to that in 2000?
Make the answer very short. 1.02. What is the ratio of the Total Labor Force (in %) in Burundi in 1996 to that in 1997?
Offer a terse response. 1.01. What is the ratio of the Total Labor Force (in %) of Gambia, The in 1996 to that in 1997?
Offer a very short reply. 1. What is the ratio of the Total Labor Force (in %) in Ireland in 1996 to that in 1997?
Offer a terse response. 0.98. What is the ratio of the Total Labor Force (in %) of Philippines in 1996 to that in 1997?
Your response must be concise. 1. What is the ratio of the Total Labor Force (in %) in Burundi in 1996 to that in 1998?
Keep it short and to the point. 1.02. What is the ratio of the Total Labor Force (in %) in Ireland in 1996 to that in 1998?
Your answer should be very brief. 0.94. What is the ratio of the Total Labor Force (in %) of Burundi in 1996 to that in 1999?
Make the answer very short. 1.02. What is the ratio of the Total Labor Force (in %) of Gambia, The in 1996 to that in 1999?
Offer a terse response. 0.99. What is the ratio of the Total Labor Force (in %) in Ireland in 1996 to that in 1999?
Your response must be concise. 0.9. What is the ratio of the Total Labor Force (in %) of Philippines in 1996 to that in 1999?
Ensure brevity in your answer.  0.98. What is the ratio of the Total Labor Force (in %) in Burundi in 1996 to that in 2000?
Your answer should be very brief. 1.03. What is the ratio of the Total Labor Force (in %) of Gambia, The in 1996 to that in 2000?
Give a very brief answer. 0.99. What is the ratio of the Total Labor Force (in %) in Ireland in 1996 to that in 2000?
Your answer should be compact. 0.88. What is the ratio of the Total Labor Force (in %) in Burundi in 1997 to that in 1998?
Give a very brief answer. 1.01. What is the ratio of the Total Labor Force (in %) of Gambia, The in 1997 to that in 1998?
Ensure brevity in your answer.  1. What is the ratio of the Total Labor Force (in %) of Ireland in 1997 to that in 1998?
Offer a terse response. 0.95. What is the ratio of the Total Labor Force (in %) in Philippines in 1997 to that in 1998?
Your answer should be compact. 0.99. What is the ratio of the Total Labor Force (in %) of Burundi in 1997 to that in 1999?
Your answer should be very brief. 1.02. What is the ratio of the Total Labor Force (in %) of Ireland in 1997 to that in 1999?
Provide a short and direct response. 0.91. What is the ratio of the Total Labor Force (in %) of Philippines in 1997 to that in 1999?
Make the answer very short. 0.98. What is the ratio of the Total Labor Force (in %) in Burundi in 1997 to that in 2000?
Your answer should be compact. 1.02. What is the ratio of the Total Labor Force (in %) in Gambia, The in 1997 to that in 2000?
Your response must be concise. 0.99. What is the ratio of the Total Labor Force (in %) of Ireland in 1997 to that in 2000?
Make the answer very short. 0.89. What is the ratio of the Total Labor Force (in %) of Philippines in 1997 to that in 2000?
Give a very brief answer. 1.01. What is the ratio of the Total Labor Force (in %) of Burundi in 1998 to that in 1999?
Your answer should be compact. 1. What is the ratio of the Total Labor Force (in %) in Gambia, The in 1998 to that in 1999?
Your response must be concise. 1. What is the ratio of the Total Labor Force (in %) of Ireland in 1998 to that in 1999?
Provide a succinct answer. 0.96. What is the ratio of the Total Labor Force (in %) in Philippines in 1998 to that in 1999?
Give a very brief answer. 0.99. What is the ratio of the Total Labor Force (in %) in Gambia, The in 1998 to that in 2000?
Keep it short and to the point. 1. What is the ratio of the Total Labor Force (in %) in Ireland in 1998 to that in 2000?
Offer a terse response. 0.94. What is the ratio of the Total Labor Force (in %) in Philippines in 1998 to that in 2000?
Provide a short and direct response. 1.02. What is the ratio of the Total Labor Force (in %) in Burundi in 1999 to that in 2000?
Your response must be concise. 1. What is the ratio of the Total Labor Force (in %) of Gambia, The in 1999 to that in 2000?
Your response must be concise. 1. What is the ratio of the Total Labor Force (in %) of Ireland in 1999 to that in 2000?
Ensure brevity in your answer.  0.98. What is the ratio of the Total Labor Force (in %) of Philippines in 1999 to that in 2000?
Make the answer very short. 1.03. What is the difference between the highest and the second highest Total Labor Force (in %) in Burundi?
Your answer should be very brief. 0.7. What is the difference between the highest and the second highest Total Labor Force (in %) in Gambia, The?
Provide a short and direct response. 0.2. What is the difference between the highest and the second highest Total Labor Force (in %) in Ireland?
Offer a terse response. 1.3. What is the difference between the highest and the lowest Total Labor Force (in %) in Philippines?
Offer a terse response. 2.3. 